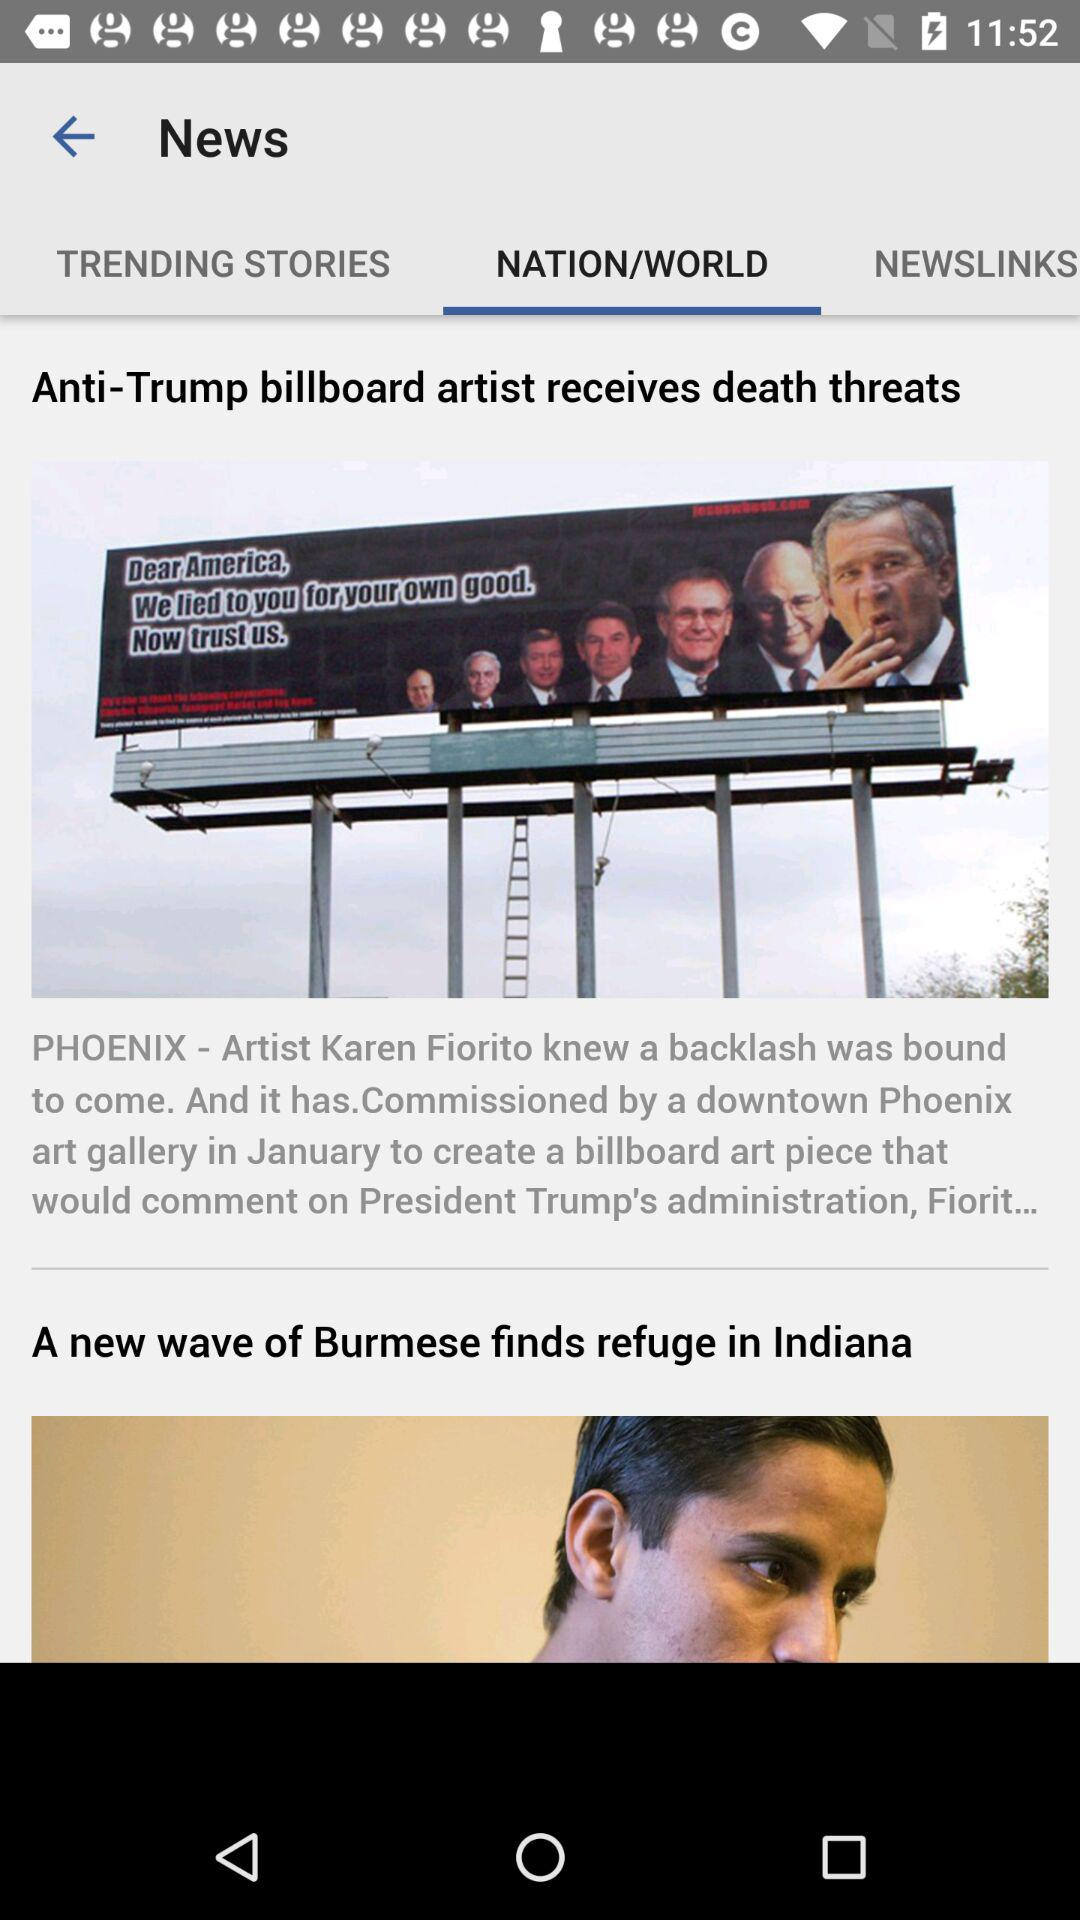What are the available headlines? The available headlines are "Anti-Trump billboard artist receives death threats" and "A new wave of Burmese finds refuge in Indiana". 